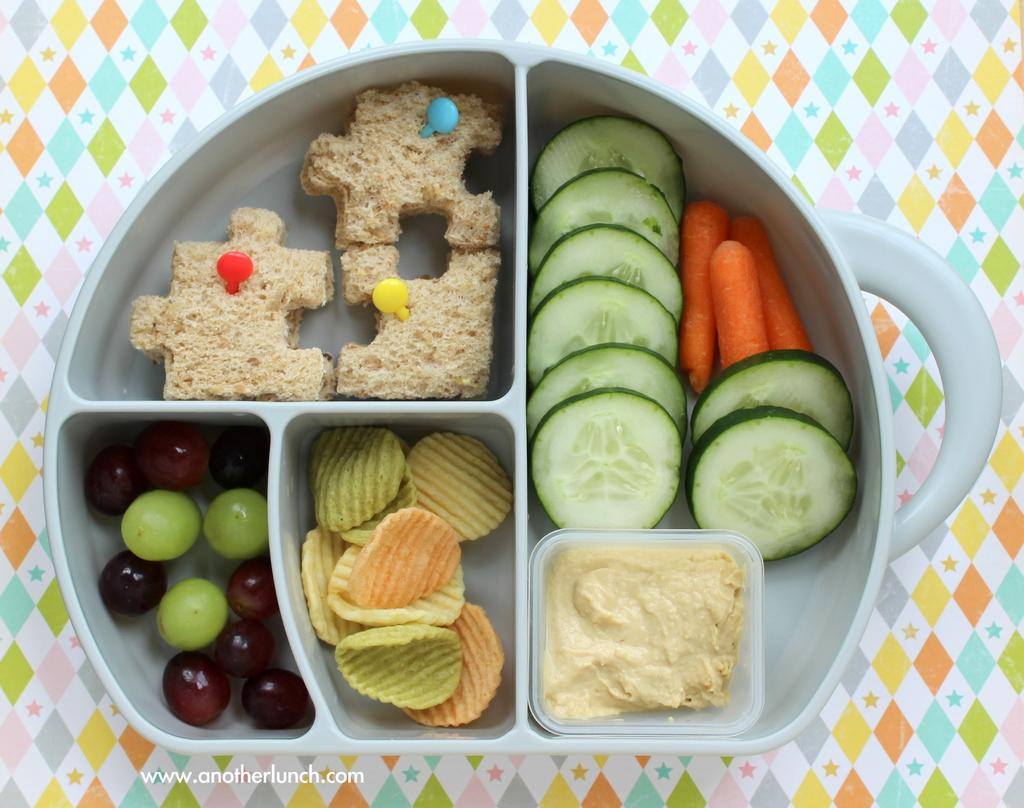What is present on the plate in the image? There are food items on a plate in the image. What is the colorful surface that the plate is on? The plate is on a colorful surface. What type of container is present in the image? There is a plastic box in the image. Where is the food located in the image? The food is in the plastic box. How is the plastic box positioned in relation to the plate? The plastic box is in the plate. What type of yarn is being used to create the food in the image? There is no yarn present in the image; the food is made of actual food items. 